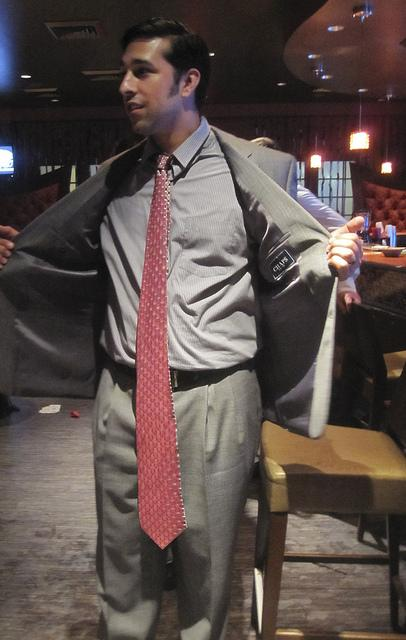What clothing item is most strangely fitting on this man? tie 